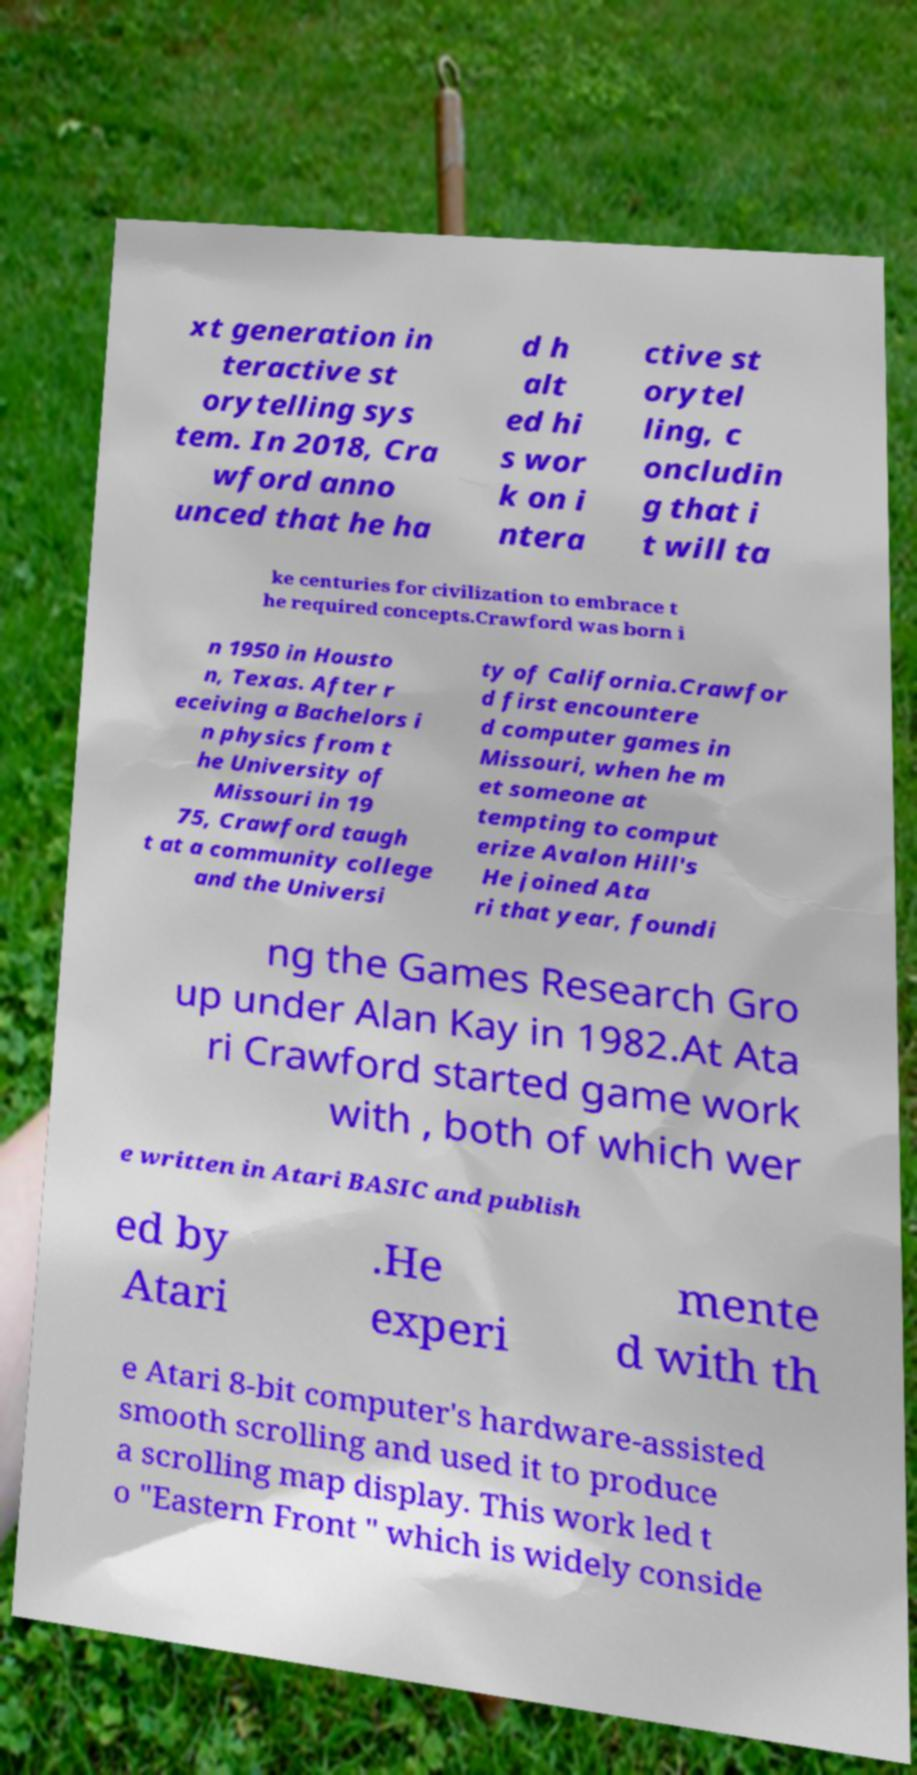Please read and relay the text visible in this image. What does it say? xt generation in teractive st orytelling sys tem. In 2018, Cra wford anno unced that he ha d h alt ed hi s wor k on i ntera ctive st orytel ling, c oncludin g that i t will ta ke centuries for civilization to embrace t he required concepts.Crawford was born i n 1950 in Housto n, Texas. After r eceiving a Bachelors i n physics from t he University of Missouri in 19 75, Crawford taugh t at a community college and the Universi ty of California.Crawfor d first encountere d computer games in Missouri, when he m et someone at tempting to comput erize Avalon Hill's He joined Ata ri that year, foundi ng the Games Research Gro up under Alan Kay in 1982.At Ata ri Crawford started game work with , both of which wer e written in Atari BASIC and publish ed by Atari .He experi mente d with th e Atari 8-bit computer's hardware-assisted smooth scrolling and used it to produce a scrolling map display. This work led t o "Eastern Front " which is widely conside 